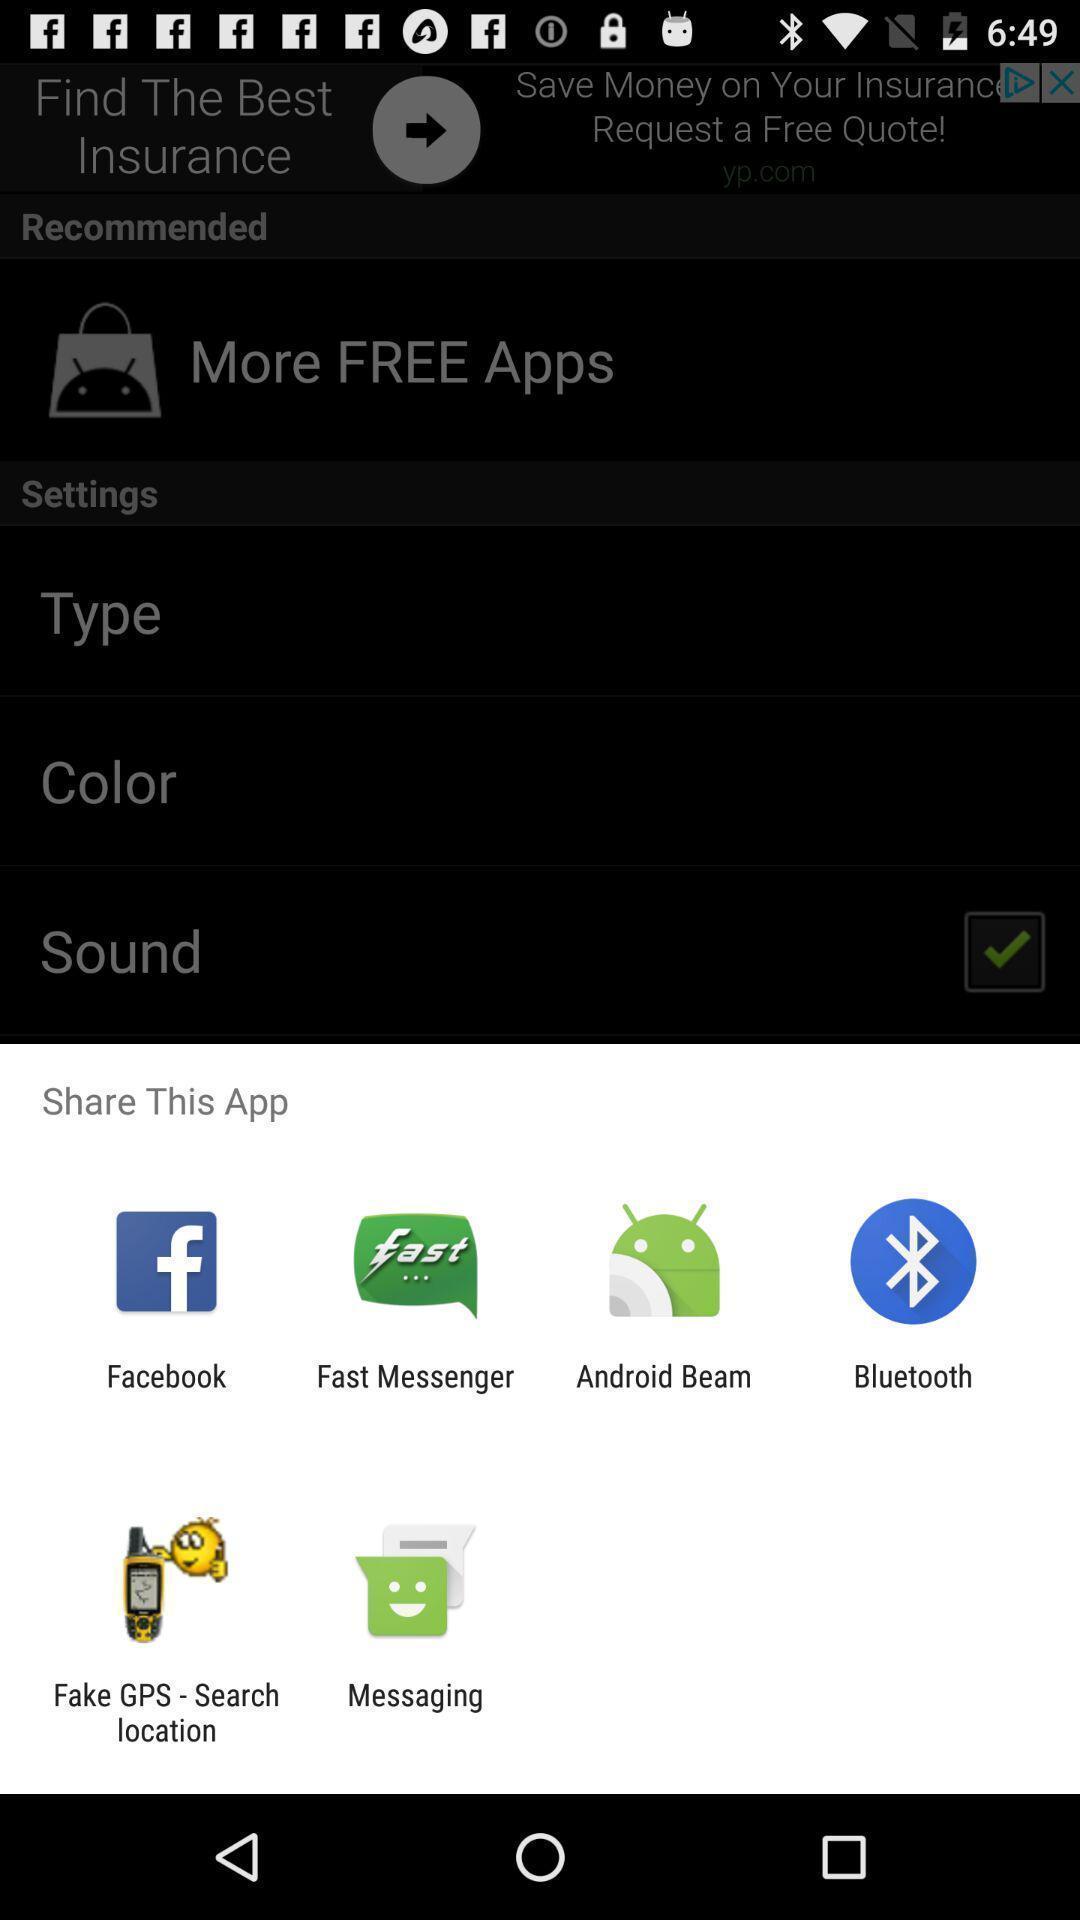Describe this image in words. Pop-up widget showing multiple data sharing apps. 